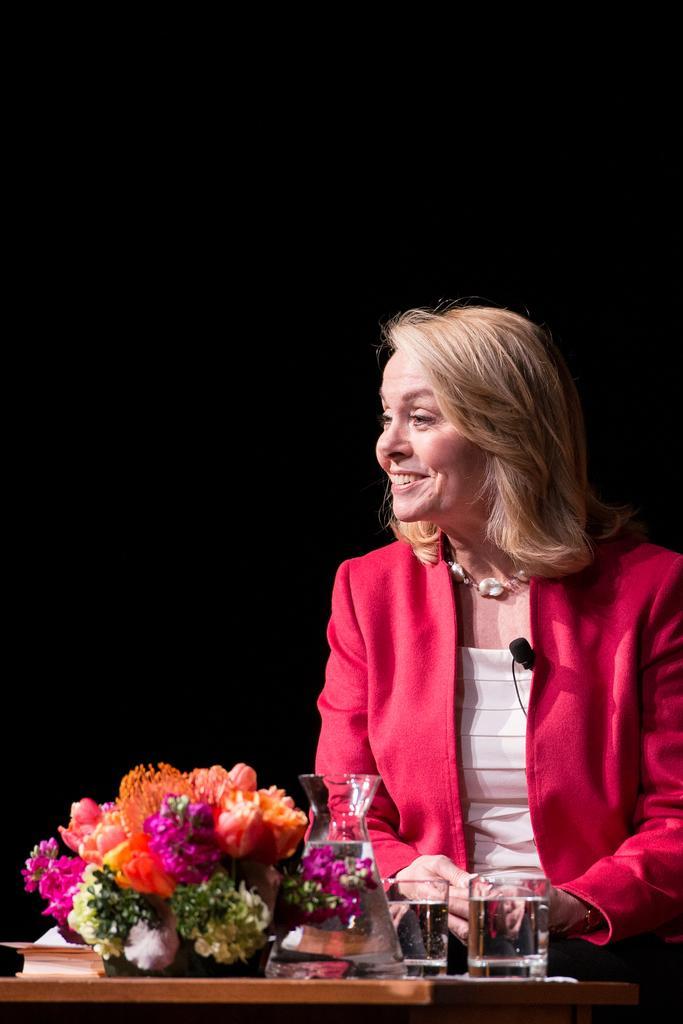Describe this image in one or two sentences. A beautiful woman is smiling, she wore red color coat. There are water glasses on this table and a bouquet of flowers. 